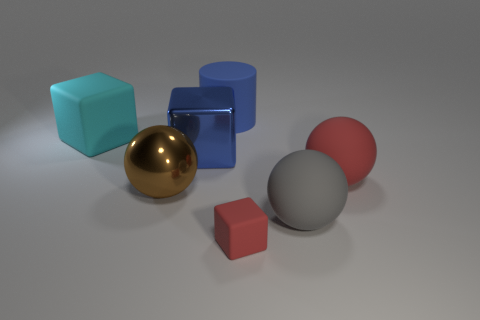What is the shape of the large red matte thing?
Provide a short and direct response. Sphere. What number of large matte cubes have the same color as the big metal cube?
Your response must be concise. 0. The big block that is to the right of the big sphere that is left of the big thing behind the cyan cube is made of what material?
Provide a short and direct response. Metal. What number of red objects are large matte cubes or shiny spheres?
Your answer should be compact. 0. There is a red matte object left of the sphere that is in front of the large ball that is left of the big blue rubber thing; what size is it?
Your response must be concise. Small. There is another metal object that is the same shape as the big red object; what size is it?
Your response must be concise. Large. What number of large things are either purple matte cubes or blue metal things?
Give a very brief answer. 1. Is the cube that is on the right side of the large blue cylinder made of the same material as the big ball that is to the left of the big blue matte cylinder?
Offer a very short reply. No. What material is the block right of the blue shiny cube?
Offer a terse response. Rubber. How many rubber objects are either small cubes or cylinders?
Your answer should be very brief. 2. 